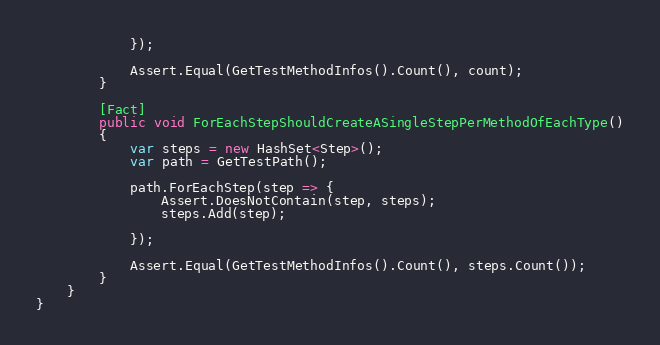Convert code to text. <code><loc_0><loc_0><loc_500><loc_500><_C#_>            });

            Assert.Equal(GetTestMethodInfos().Count(), count);
        }

        [Fact]
        public void ForEachStepShouldCreateASingleStepPerMethodOfEachType()
        {
            var steps = new HashSet<Step>();
            var path = GetTestPath();

            path.ForEachStep(step => {
                Assert.DoesNotContain(step, steps);
                steps.Add(step);
               
            });

            Assert.Equal(GetTestMethodInfos().Count(), steps.Count());
        }
    }
}</code> 